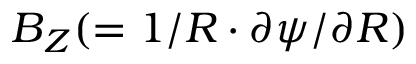Convert formula to latex. <formula><loc_0><loc_0><loc_500><loc_500>B _ { Z } ( = 1 / R \cdot \partial \psi / \partial R )</formula> 